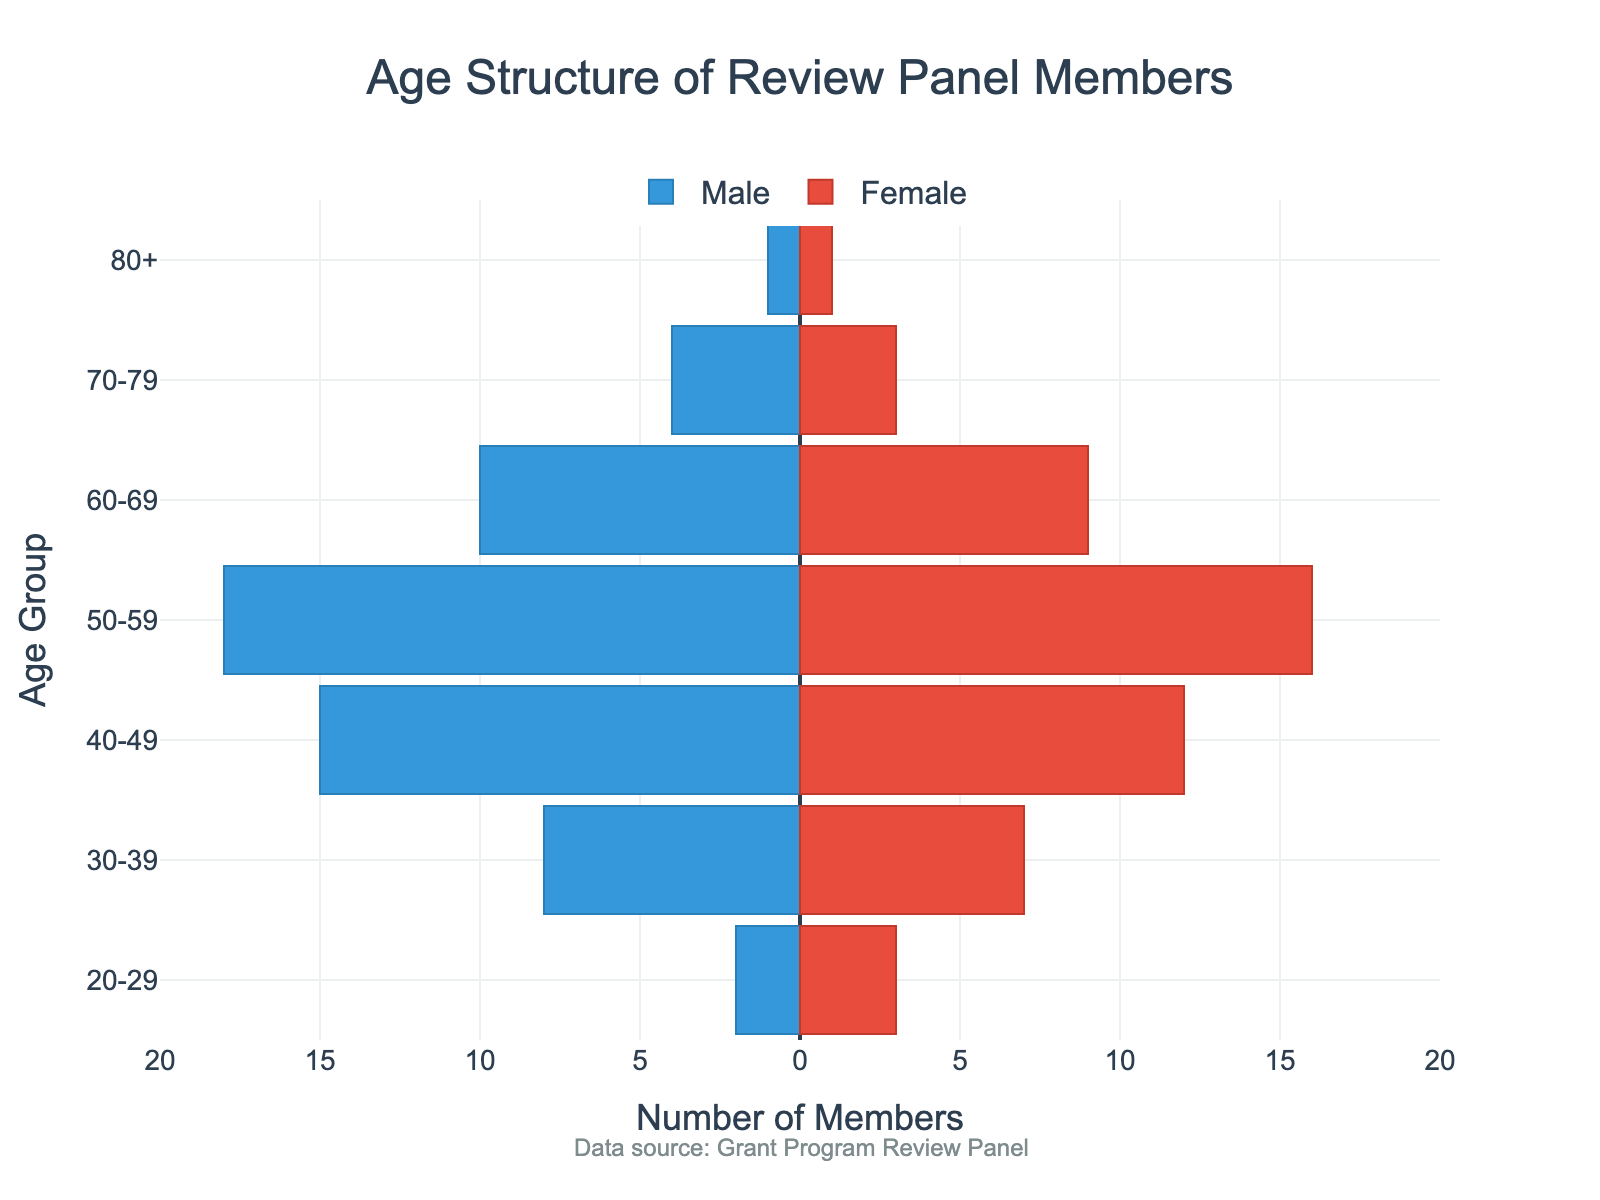What is the title of the figure? The title of the figure is typically located at the top of the figure. In this case, it is "Age Structure of Review Panel Members".
Answer: Age Structure of Review Panel Members How many members are in the 40-49 age range? The figure shows positive (female) and negative (male) bars associated with each age range. Adding both values for 40-49, we get 15 males and 12 females, which totals to 27 members.
Answer: 27 Which age group has the highest number of female members? By examining the length of the positive (red) bars for each age group, the 50-59 age group has the longest bar, corresponding to 16 female members.
Answer: 50-59 How many more males are there than females in the 30-39 age group? The number of males in the 30-39 age group is 8 and the number of females is 7. Subtracting the number of females from males, we get 8 - 7 = 1.
Answer: 1 Which gender has more members in the 70-79 age group and by how many? The 70-79 age group has 4 males and 3 females. Comparing the two, there is 1 more male than female.
Answer: Males, 1 What is the total number of members aged 20-29? Adding the number of males (2) and females (3) in the 20-29 age group, we get 2 + 3 = 5 members.
Answer: 5 Is there any age group where the number of male and female members are equal? By examining the figure, we can see that only the 80+ age group has equal numbers of males and females, both being 1.
Answer: 80+ How many members are 50 years old or older? Adding the number of members in the 50-59, 60-69, 70-79, and 80+ age groups, we get (34) + (19) + (7) + (2) = 62 members.
Answer: 62 Which age group has the fewest members overall? By examining the figure, the 80+ age group has the shortest bars, indicating the least number of members, totaling 2.
Answer: 80+ How does the number of females in the 30-39 age group compare to those in the 50-59 age group? The number of females in the 30-39 age group is 7, while in the 50-59 age group, it is 16. Therefore, the 50-59 age group has more female members.
Answer: There are more females in the 50-59 age group 